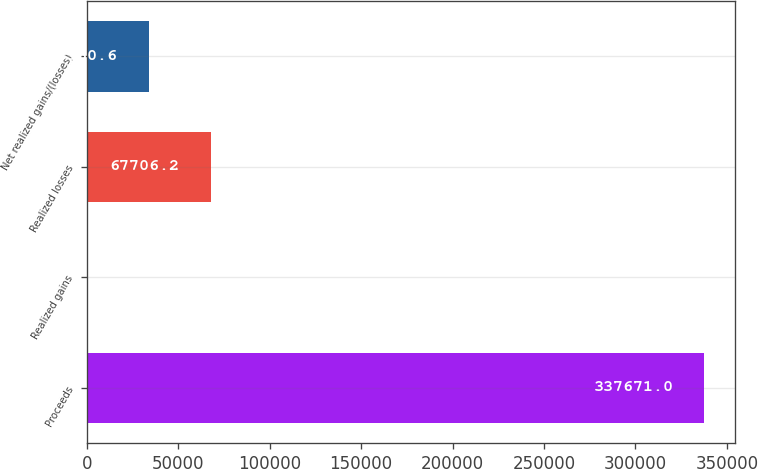Convert chart to OTSL. <chart><loc_0><loc_0><loc_500><loc_500><bar_chart><fcel>Proceeds<fcel>Realized gains<fcel>Realized losses<fcel>Net realized gains/(losses)<nl><fcel>337671<fcel>215<fcel>67706.2<fcel>33960.6<nl></chart> 